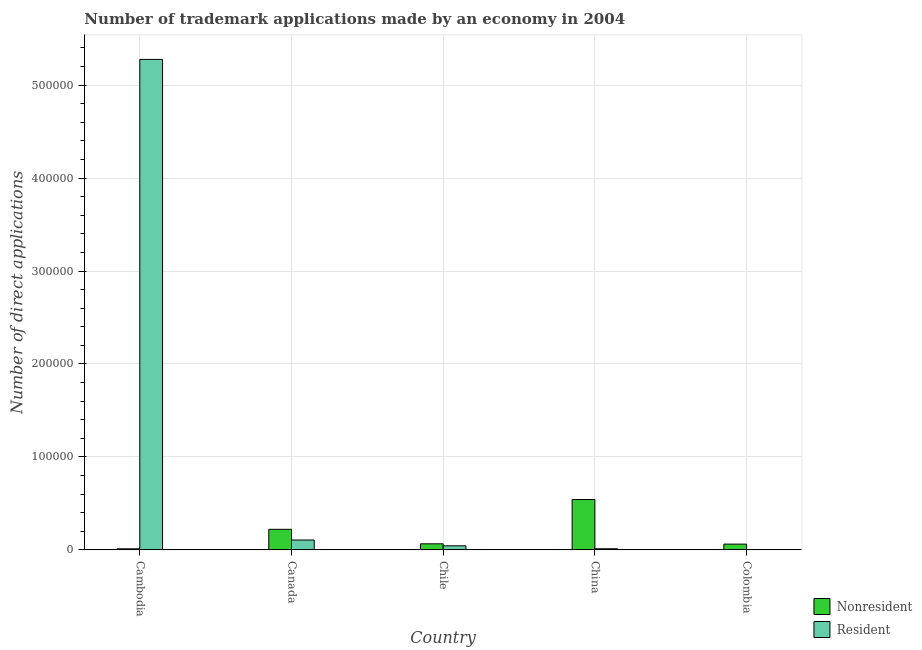How many groups of bars are there?
Offer a very short reply. 5. Are the number of bars per tick equal to the number of legend labels?
Provide a short and direct response. Yes. How many bars are there on the 4th tick from the left?
Ensure brevity in your answer.  2. How many bars are there on the 4th tick from the right?
Your response must be concise. 2. In how many cases, is the number of bars for a given country not equal to the number of legend labels?
Provide a succinct answer. 0. What is the number of trademark applications made by non residents in Colombia?
Your response must be concise. 6251. Across all countries, what is the maximum number of trademark applications made by non residents?
Keep it short and to the point. 5.42e+04. Across all countries, what is the minimum number of trademark applications made by non residents?
Make the answer very short. 1192. In which country was the number of trademark applications made by residents maximum?
Your answer should be compact. Cambodia. In which country was the number of trademark applications made by non residents minimum?
Provide a short and direct response. Cambodia. What is the total number of trademark applications made by residents in the graph?
Make the answer very short. 5.44e+05. What is the difference between the number of trademark applications made by residents in Canada and that in China?
Keep it short and to the point. 9396. What is the difference between the number of trademark applications made by non residents in China and the number of trademark applications made by residents in Canada?
Offer a very short reply. 4.35e+04. What is the average number of trademark applications made by non residents per country?
Keep it short and to the point. 1.81e+04. What is the difference between the number of trademark applications made by residents and number of trademark applications made by non residents in Colombia?
Your answer should be compact. -5872. What is the ratio of the number of trademark applications made by non residents in Canada to that in Chile?
Your answer should be very brief. 3.37. Is the number of trademark applications made by non residents in Canada less than that in China?
Give a very brief answer. Yes. Is the difference between the number of trademark applications made by residents in Cambodia and China greater than the difference between the number of trademark applications made by non residents in Cambodia and China?
Offer a terse response. Yes. What is the difference between the highest and the second highest number of trademark applications made by residents?
Make the answer very short. 5.17e+05. What is the difference between the highest and the lowest number of trademark applications made by non residents?
Offer a terse response. 5.30e+04. Is the sum of the number of trademark applications made by non residents in China and Colombia greater than the maximum number of trademark applications made by residents across all countries?
Give a very brief answer. No. What does the 1st bar from the left in Cambodia represents?
Provide a succinct answer. Nonresident. What does the 1st bar from the right in Cambodia represents?
Offer a terse response. Resident. How many countries are there in the graph?
Provide a succinct answer. 5. What is the difference between two consecutive major ticks on the Y-axis?
Provide a short and direct response. 1.00e+05. Are the values on the major ticks of Y-axis written in scientific E-notation?
Ensure brevity in your answer.  No. Does the graph contain any zero values?
Keep it short and to the point. No. Where does the legend appear in the graph?
Offer a terse response. Bottom right. How many legend labels are there?
Your response must be concise. 2. What is the title of the graph?
Make the answer very short. Number of trademark applications made by an economy in 2004. Does "Urban" appear as one of the legend labels in the graph?
Offer a very short reply. No. What is the label or title of the X-axis?
Your answer should be very brief. Country. What is the label or title of the Y-axis?
Ensure brevity in your answer.  Number of direct applications. What is the Number of direct applications in Nonresident in Cambodia?
Ensure brevity in your answer.  1192. What is the Number of direct applications in Resident in Cambodia?
Offer a terse response. 5.28e+05. What is the Number of direct applications of Nonresident in Canada?
Your response must be concise. 2.22e+04. What is the Number of direct applications of Resident in Canada?
Offer a very short reply. 1.07e+04. What is the Number of direct applications in Nonresident in Chile?
Provide a short and direct response. 6576. What is the Number of direct applications of Resident in Chile?
Your answer should be very brief. 4444. What is the Number of direct applications in Nonresident in China?
Make the answer very short. 5.42e+04. What is the Number of direct applications in Resident in China?
Offer a very short reply. 1283. What is the Number of direct applications of Nonresident in Colombia?
Keep it short and to the point. 6251. What is the Number of direct applications of Resident in Colombia?
Your response must be concise. 379. Across all countries, what is the maximum Number of direct applications of Nonresident?
Your response must be concise. 5.42e+04. Across all countries, what is the maximum Number of direct applications of Resident?
Offer a terse response. 5.28e+05. Across all countries, what is the minimum Number of direct applications in Nonresident?
Your answer should be very brief. 1192. Across all countries, what is the minimum Number of direct applications of Resident?
Your answer should be compact. 379. What is the total Number of direct applications in Nonresident in the graph?
Keep it short and to the point. 9.04e+04. What is the total Number of direct applications in Resident in the graph?
Your answer should be very brief. 5.44e+05. What is the difference between the Number of direct applications in Nonresident in Cambodia and that in Canada?
Offer a terse response. -2.10e+04. What is the difference between the Number of direct applications of Resident in Cambodia and that in Canada?
Make the answer very short. 5.17e+05. What is the difference between the Number of direct applications of Nonresident in Cambodia and that in Chile?
Offer a very short reply. -5384. What is the difference between the Number of direct applications of Resident in Cambodia and that in Chile?
Make the answer very short. 5.23e+05. What is the difference between the Number of direct applications in Nonresident in Cambodia and that in China?
Ensure brevity in your answer.  -5.30e+04. What is the difference between the Number of direct applications in Resident in Cambodia and that in China?
Offer a very short reply. 5.26e+05. What is the difference between the Number of direct applications in Nonresident in Cambodia and that in Colombia?
Offer a terse response. -5059. What is the difference between the Number of direct applications in Resident in Cambodia and that in Colombia?
Your answer should be compact. 5.27e+05. What is the difference between the Number of direct applications of Nonresident in Canada and that in Chile?
Provide a short and direct response. 1.56e+04. What is the difference between the Number of direct applications in Resident in Canada and that in Chile?
Your response must be concise. 6235. What is the difference between the Number of direct applications of Nonresident in Canada and that in China?
Your response must be concise. -3.20e+04. What is the difference between the Number of direct applications in Resident in Canada and that in China?
Offer a very short reply. 9396. What is the difference between the Number of direct applications in Nonresident in Canada and that in Colombia?
Make the answer very short. 1.59e+04. What is the difference between the Number of direct applications in Resident in Canada and that in Colombia?
Provide a succinct answer. 1.03e+04. What is the difference between the Number of direct applications of Nonresident in Chile and that in China?
Your response must be concise. -4.76e+04. What is the difference between the Number of direct applications of Resident in Chile and that in China?
Offer a very short reply. 3161. What is the difference between the Number of direct applications in Nonresident in Chile and that in Colombia?
Give a very brief answer. 325. What is the difference between the Number of direct applications in Resident in Chile and that in Colombia?
Your response must be concise. 4065. What is the difference between the Number of direct applications of Nonresident in China and that in Colombia?
Provide a succinct answer. 4.80e+04. What is the difference between the Number of direct applications in Resident in China and that in Colombia?
Keep it short and to the point. 904. What is the difference between the Number of direct applications of Nonresident in Cambodia and the Number of direct applications of Resident in Canada?
Your response must be concise. -9487. What is the difference between the Number of direct applications in Nonresident in Cambodia and the Number of direct applications in Resident in Chile?
Offer a very short reply. -3252. What is the difference between the Number of direct applications of Nonresident in Cambodia and the Number of direct applications of Resident in China?
Make the answer very short. -91. What is the difference between the Number of direct applications in Nonresident in Cambodia and the Number of direct applications in Resident in Colombia?
Give a very brief answer. 813. What is the difference between the Number of direct applications of Nonresident in Canada and the Number of direct applications of Resident in Chile?
Offer a terse response. 1.77e+04. What is the difference between the Number of direct applications in Nonresident in Canada and the Number of direct applications in Resident in China?
Give a very brief answer. 2.09e+04. What is the difference between the Number of direct applications of Nonresident in Canada and the Number of direct applications of Resident in Colombia?
Give a very brief answer. 2.18e+04. What is the difference between the Number of direct applications in Nonresident in Chile and the Number of direct applications in Resident in China?
Your answer should be compact. 5293. What is the difference between the Number of direct applications in Nonresident in Chile and the Number of direct applications in Resident in Colombia?
Offer a terse response. 6197. What is the difference between the Number of direct applications of Nonresident in China and the Number of direct applications of Resident in Colombia?
Offer a terse response. 5.38e+04. What is the average Number of direct applications in Nonresident per country?
Keep it short and to the point. 1.81e+04. What is the average Number of direct applications in Resident per country?
Give a very brief answer. 1.09e+05. What is the difference between the Number of direct applications of Nonresident and Number of direct applications of Resident in Cambodia?
Keep it short and to the point. -5.26e+05. What is the difference between the Number of direct applications of Nonresident and Number of direct applications of Resident in Canada?
Your answer should be compact. 1.15e+04. What is the difference between the Number of direct applications of Nonresident and Number of direct applications of Resident in Chile?
Offer a very short reply. 2132. What is the difference between the Number of direct applications in Nonresident and Number of direct applications in Resident in China?
Give a very brief answer. 5.29e+04. What is the difference between the Number of direct applications of Nonresident and Number of direct applications of Resident in Colombia?
Provide a succinct answer. 5872. What is the ratio of the Number of direct applications in Nonresident in Cambodia to that in Canada?
Your answer should be very brief. 0.05. What is the ratio of the Number of direct applications of Resident in Cambodia to that in Canada?
Offer a terse response. 49.4. What is the ratio of the Number of direct applications of Nonresident in Cambodia to that in Chile?
Provide a succinct answer. 0.18. What is the ratio of the Number of direct applications of Resident in Cambodia to that in Chile?
Your answer should be very brief. 118.72. What is the ratio of the Number of direct applications in Nonresident in Cambodia to that in China?
Your response must be concise. 0.02. What is the ratio of the Number of direct applications of Resident in Cambodia to that in China?
Make the answer very short. 411.22. What is the ratio of the Number of direct applications of Nonresident in Cambodia to that in Colombia?
Your answer should be very brief. 0.19. What is the ratio of the Number of direct applications in Resident in Cambodia to that in Colombia?
Provide a succinct answer. 1392.06. What is the ratio of the Number of direct applications in Nonresident in Canada to that in Chile?
Ensure brevity in your answer.  3.37. What is the ratio of the Number of direct applications in Resident in Canada to that in Chile?
Offer a terse response. 2.4. What is the ratio of the Number of direct applications of Nonresident in Canada to that in China?
Provide a succinct answer. 0.41. What is the ratio of the Number of direct applications of Resident in Canada to that in China?
Provide a short and direct response. 8.32. What is the ratio of the Number of direct applications of Nonresident in Canada to that in Colombia?
Give a very brief answer. 3.55. What is the ratio of the Number of direct applications of Resident in Canada to that in Colombia?
Ensure brevity in your answer.  28.18. What is the ratio of the Number of direct applications in Nonresident in Chile to that in China?
Keep it short and to the point. 0.12. What is the ratio of the Number of direct applications in Resident in Chile to that in China?
Your answer should be very brief. 3.46. What is the ratio of the Number of direct applications of Nonresident in Chile to that in Colombia?
Keep it short and to the point. 1.05. What is the ratio of the Number of direct applications in Resident in Chile to that in Colombia?
Give a very brief answer. 11.73. What is the ratio of the Number of direct applications in Nonresident in China to that in Colombia?
Give a very brief answer. 8.67. What is the ratio of the Number of direct applications in Resident in China to that in Colombia?
Make the answer very short. 3.39. What is the difference between the highest and the second highest Number of direct applications in Nonresident?
Your answer should be compact. 3.20e+04. What is the difference between the highest and the second highest Number of direct applications in Resident?
Keep it short and to the point. 5.17e+05. What is the difference between the highest and the lowest Number of direct applications of Nonresident?
Your answer should be very brief. 5.30e+04. What is the difference between the highest and the lowest Number of direct applications in Resident?
Your answer should be compact. 5.27e+05. 